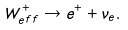Convert formula to latex. <formula><loc_0><loc_0><loc_500><loc_500>W _ { e f f } ^ { + } \to e ^ { + } + \nu _ { e } .</formula> 